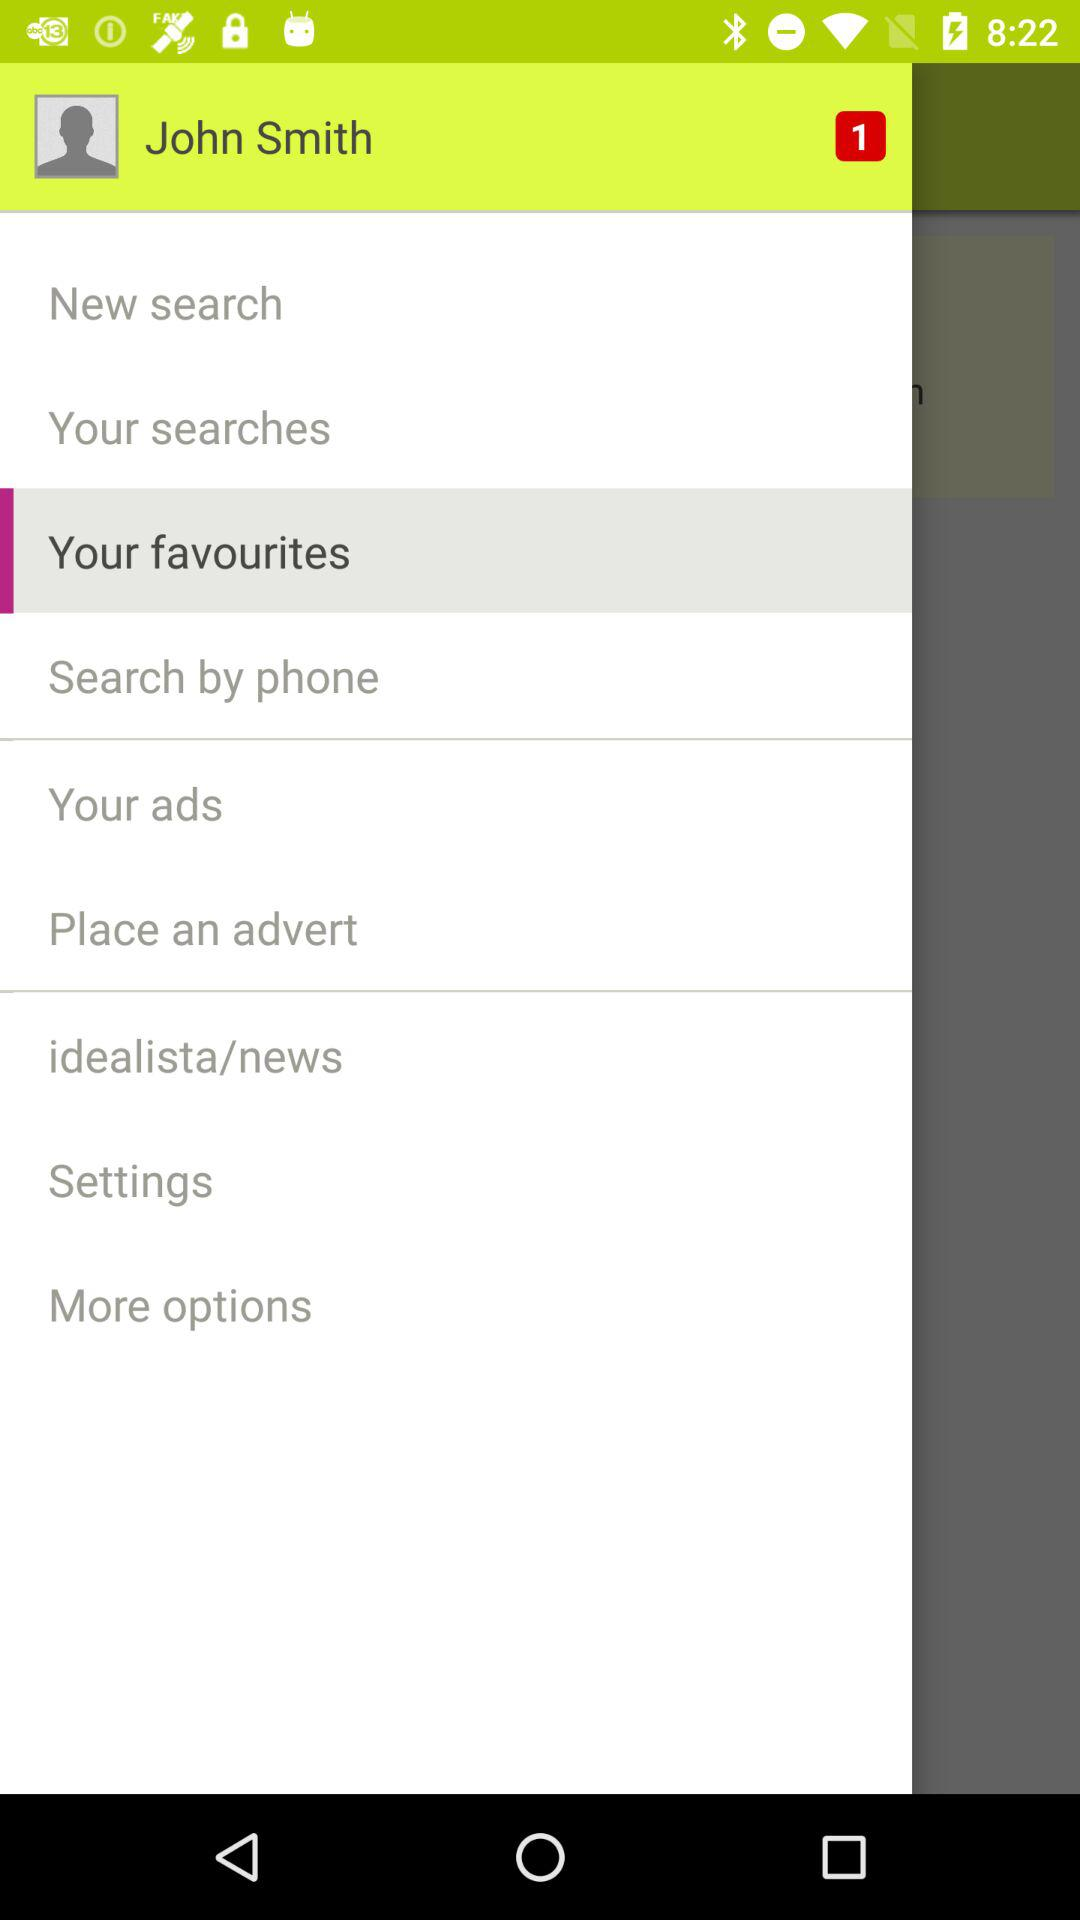What is the name of the user? The user name is John Smith. 